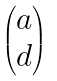<formula> <loc_0><loc_0><loc_500><loc_500>\begin{pmatrix} a \\ d \end{pmatrix}</formula> 